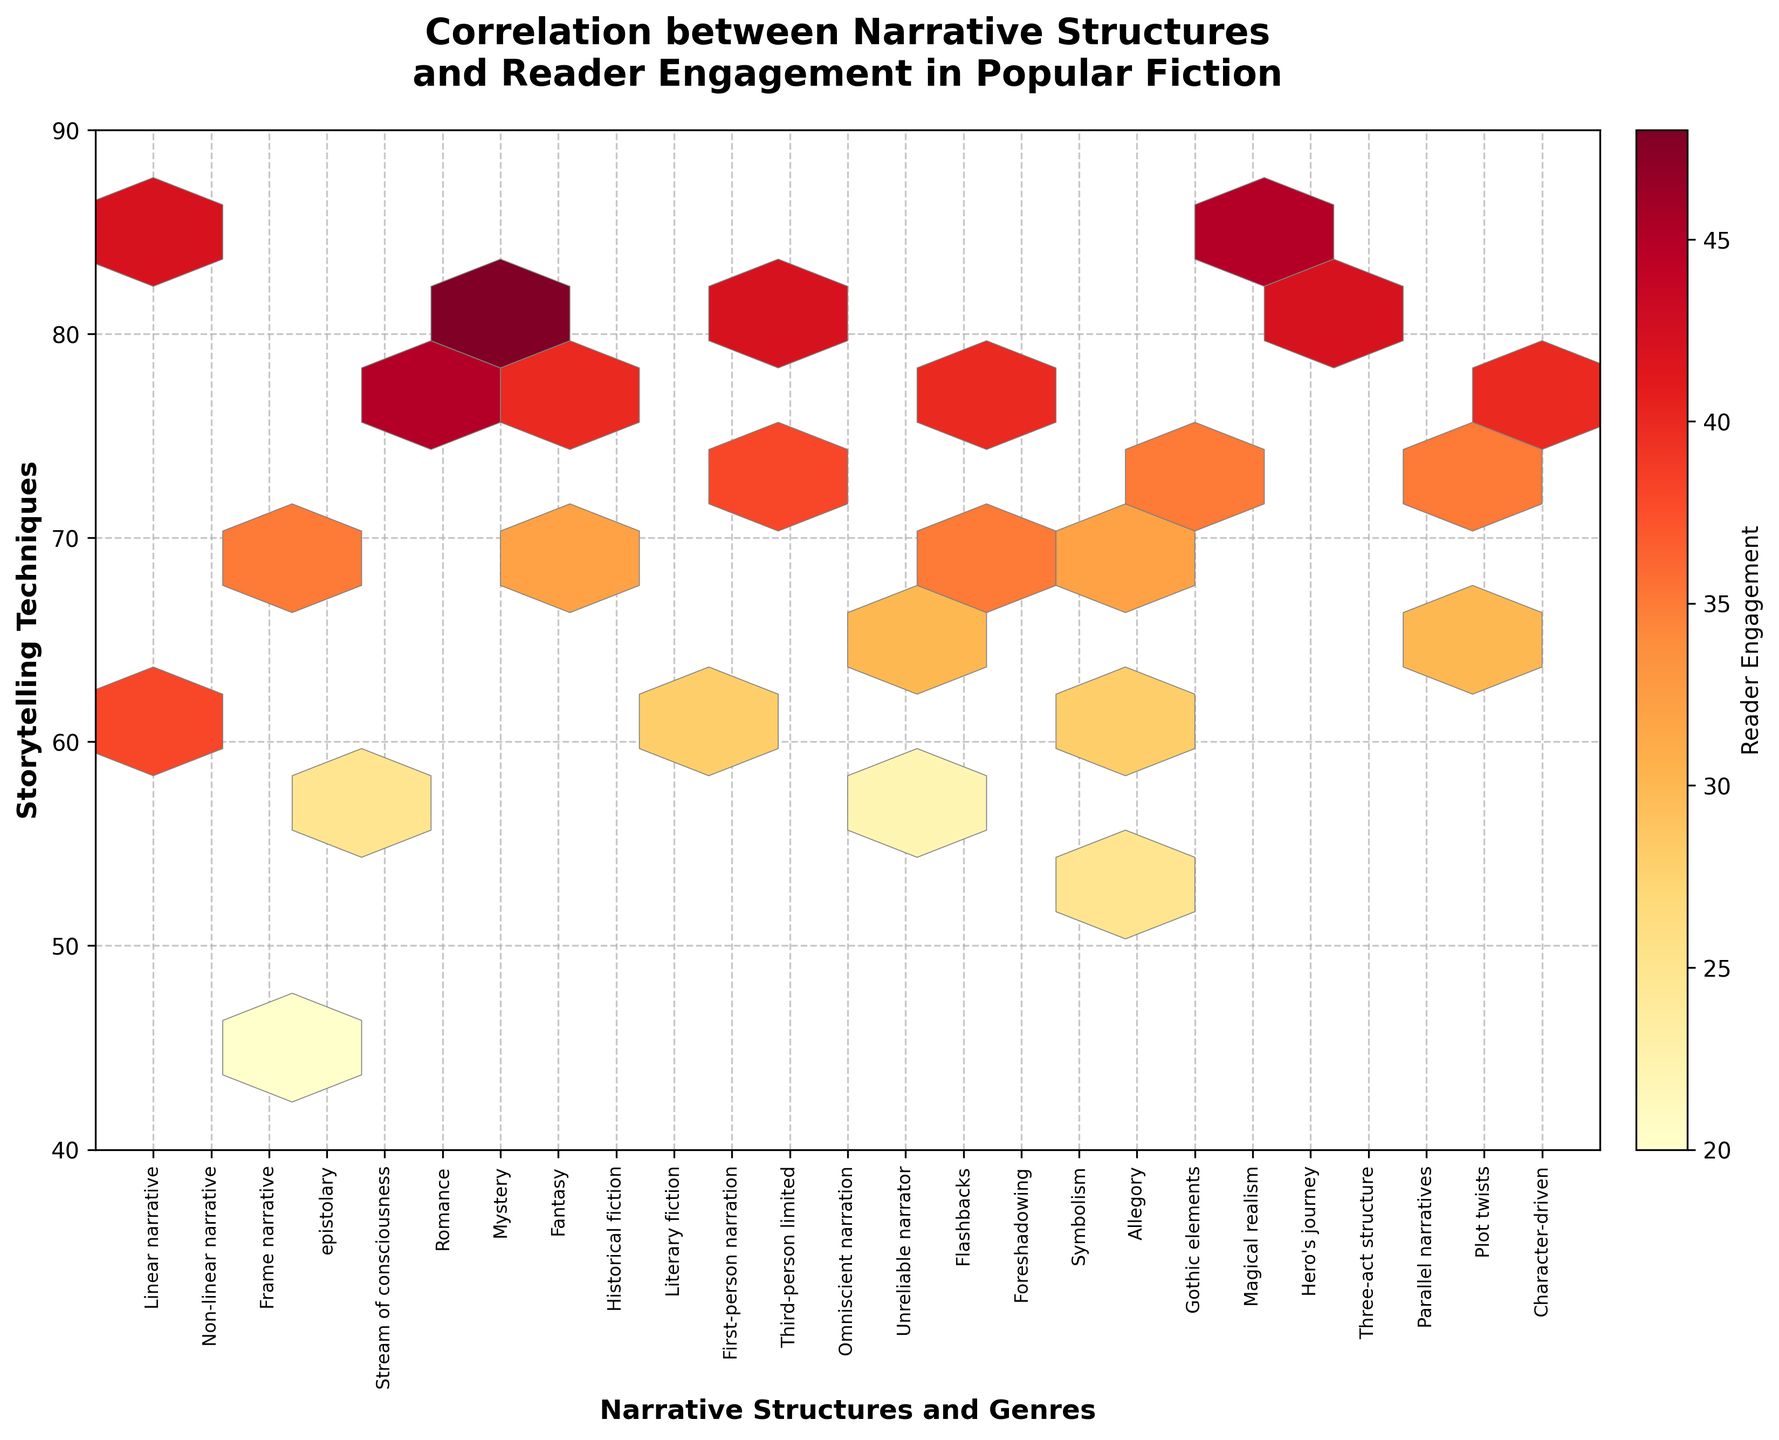What is the title of the hexbin plot? The title of the hexbin plot is usually located at the top of the figure. It provides an overview of what the plot represents. In this case, the title is "Correlation between Narrative Structures and Reader Engagement in Popular Fiction."
Answer: Correlation between Narrative Structures and Reader Engagement in Popular Fiction Which narrative structure has the highest reader engagement? The hexbin plot visualizes reader engagement as color intensity. By examining the plot, it's evident that the narrative structure "Hero's journey" is associated with the highest engagement values.
Answer: Hero's journey How many hexagons are depicted in the figure? Counting the hexagons in a hexbin plot requires careful observation. Each hexagon represents a binned value of reader engagement. This plot features 10 grids across both axes, summing up to a total of 10 x 10 = 100 hexagons.
Answer: 100 Which storytelling technique coincides with a reader engagement of 45? Identifying reader engagement levels involves examining the individual data points and their corresponding engagement values. Techniques like "Romance" and "Hero's journey" display a reader engagement of 45.
Answer: Romance, Hero's journey Which genre shows less reader engagement compared to mystery? The reader engagement for "Mystery" is high. By comparing alongside, "Epistolary" and "Gothic elements" display comparatively less reader engagement than "Mystery".
Answer: Epistolary, Gothic elements Which storytelling technique exhibits the lowest reader engagement? Scanning the plot for the least intense color represents the lowest reader engagement. The narrative technique "Epistolary" maintains the lowest engagement value of 20.
Answer: Epistolary What relationship exists between "Symbolism" and "Allegory" in terms of reader engagement? Comparing the positions and color intensities of "Symbolism" and "Allegory" within the hexbin plot indicates they share similar reader engagement levels, both generating engagement values of 25.
Answer: Similar engagement What is the range of storytelling techniques in the hexbin plot? Reviewing the y-axis for the min and max values, it starts from "Epistolary" (lowest) to "Mystery" (highest), thus encapsulating a range from 20 to 48.
Answer: 20 to 48 How do "Frame narrative" and "Omniscient narration" compare in reader engagement? Comparing color intensities and the engagement values, "Frame narrative" generates higher reader engagement (35) compared to "Omniscient narration" (30).
Answer: Frame narrative has higher engagement What's the difference in reader engagement between "Non-linear narrative" and "Stream of consciousness"? By referring to their positions on the hexbin plot, "Non-linear narrative" shows an engagement of 38, while "Stream of consciousness" is 25. The difference is 38 - 25 = 13.
Answer: 13 